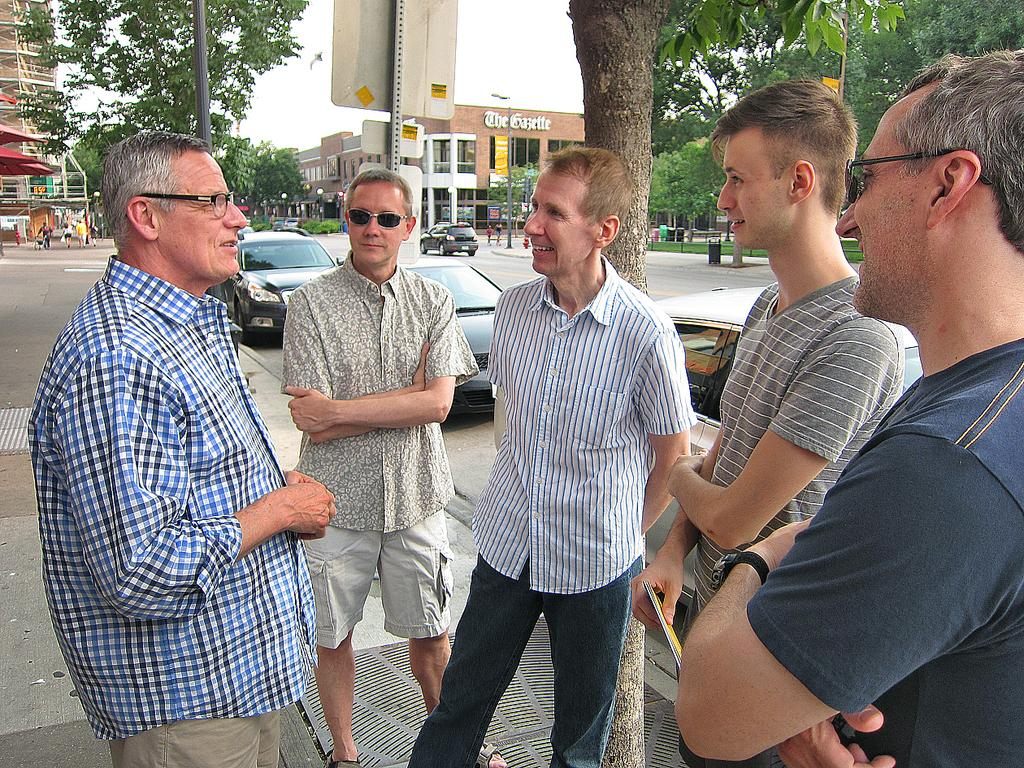What are the people in the image doing? The people in the image are standing on a road. What can be seen in the background of the image? In the background of the image, there are cars, trees, buildings, and the sky. Can you describe the setting of the image? The image shows people standing on a road with cars, trees, buildings, and the sky visible in the background. What type of underwear are the people wearing in the image? There is no information about the people's underwear in the image, as it is not visible or mentioned in the provided facts. 